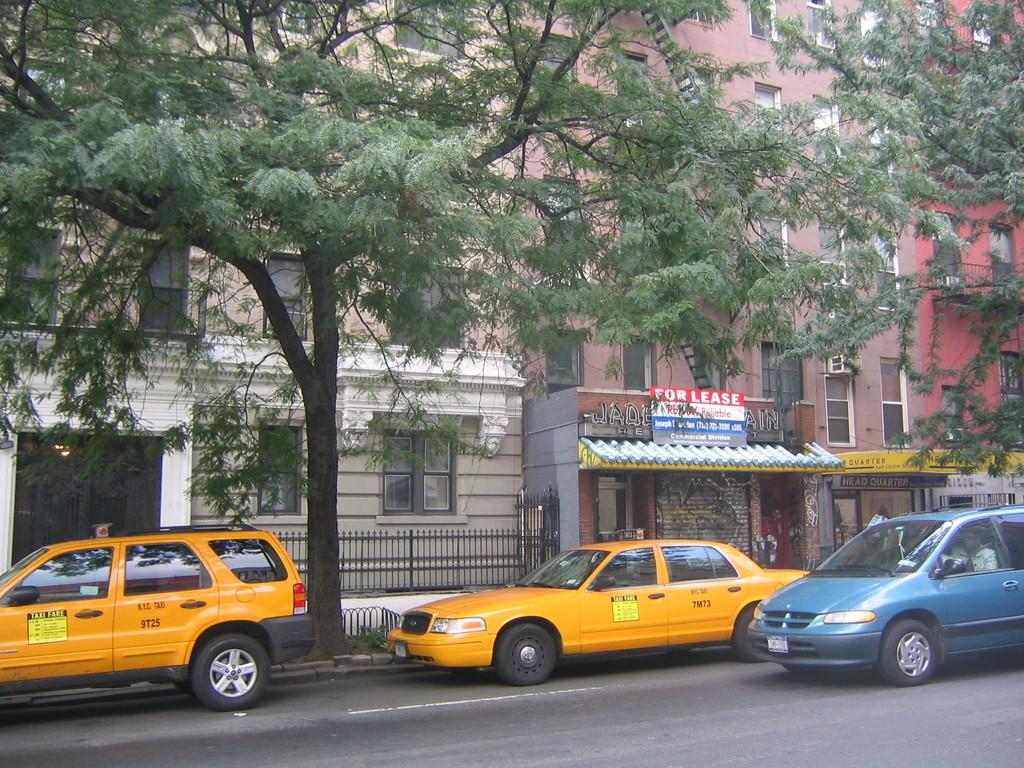What types of this car?
Keep it short and to the point. Taxi. 